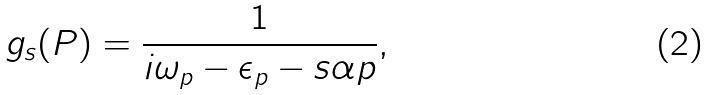Convert formula to latex. <formula><loc_0><loc_0><loc_500><loc_500>g _ { s } ( P ) = \frac { 1 } { i \omega _ { p } - \epsilon _ { p } - s \alpha p } ,</formula> 